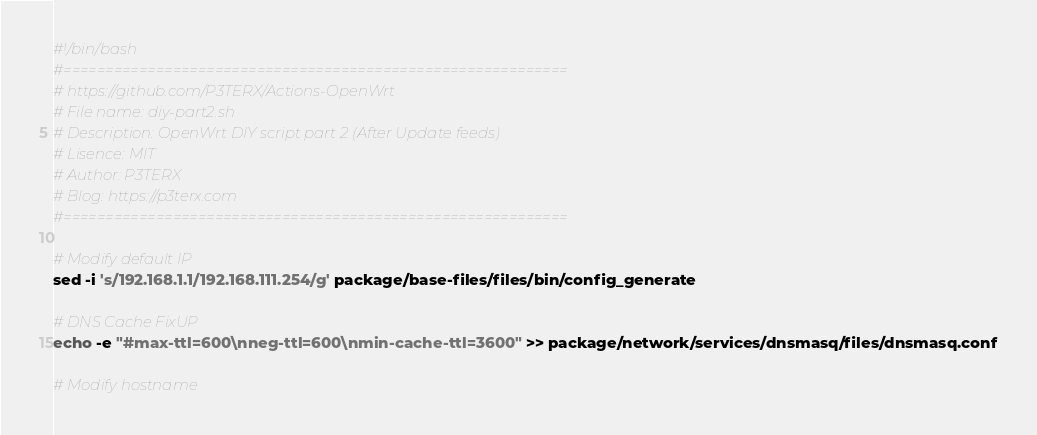<code> <loc_0><loc_0><loc_500><loc_500><_Bash_>#!/bin/bash
#============================================================
# https://github.com/P3TERX/Actions-OpenWrt
# File name: diy-part2.sh
# Description: OpenWrt DIY script part 2 (After Update feeds)
# Lisence: MIT
# Author: P3TERX
# Blog: https://p3terx.com
#============================================================

# Modify default IP
sed -i 's/192.168.1.1/192.168.111.254/g' package/base-files/files/bin/config_generate

# DNS Cache FixUP
echo -e "#max-ttl=600\nneg-ttl=600\nmin-cache-ttl=3600" >> package/network/services/dnsmasq/files/dnsmasq.conf

# Modify hostname</code> 